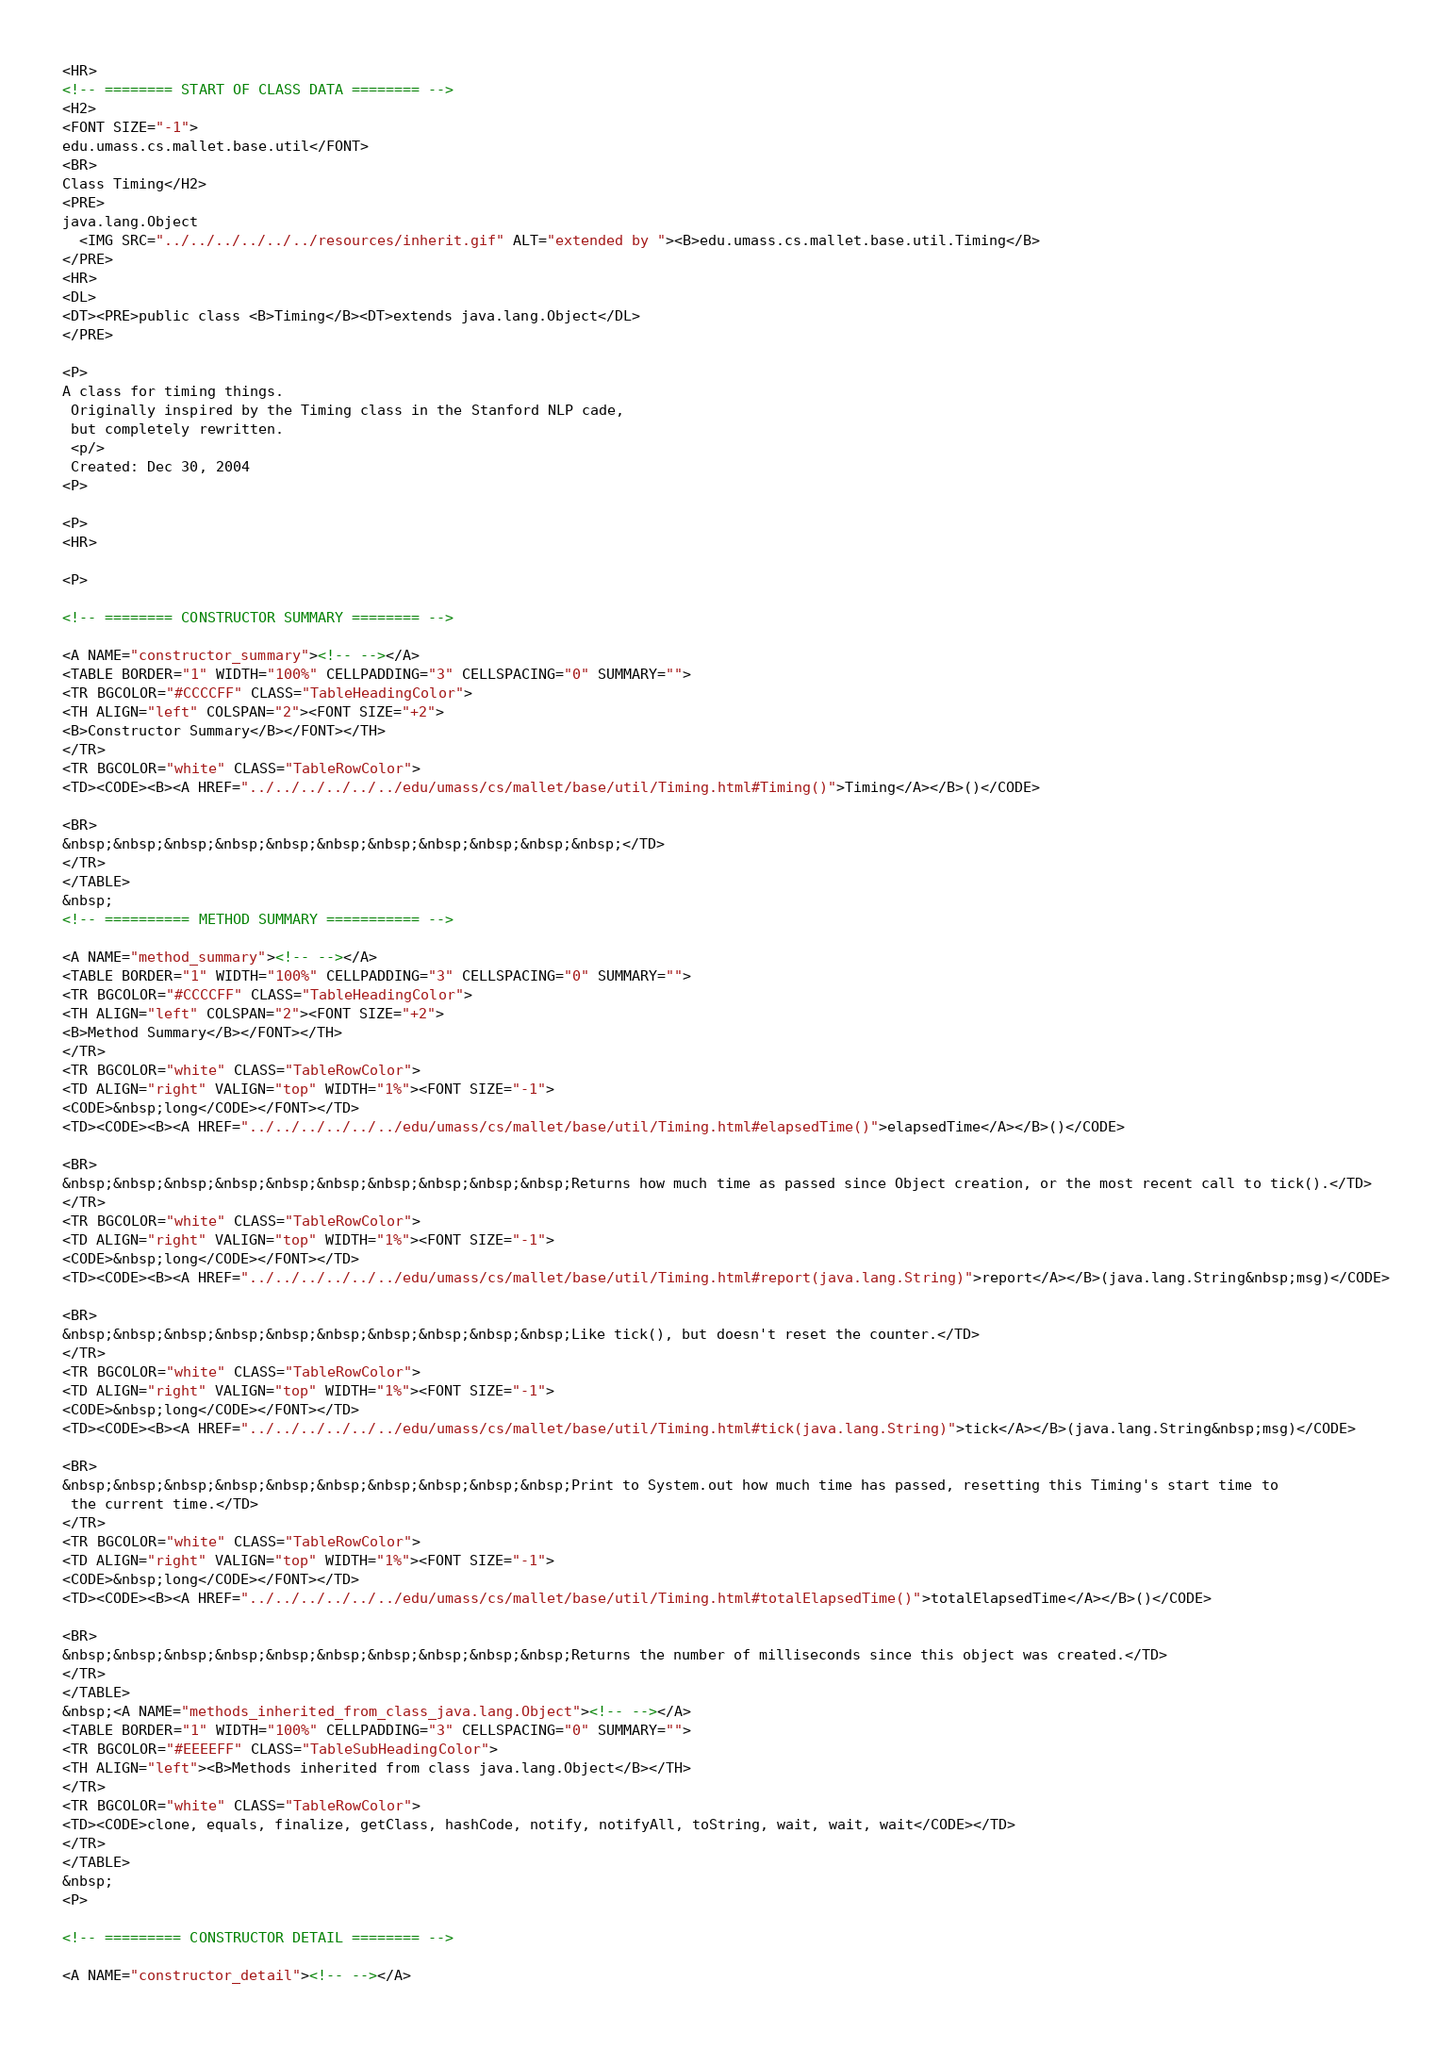<code> <loc_0><loc_0><loc_500><loc_500><_HTML_>
<HR>
<!-- ======== START OF CLASS DATA ======== -->
<H2>
<FONT SIZE="-1">
edu.umass.cs.mallet.base.util</FONT>
<BR>
Class Timing</H2>
<PRE>
java.lang.Object
  <IMG SRC="../../../../../../resources/inherit.gif" ALT="extended by "><B>edu.umass.cs.mallet.base.util.Timing</B>
</PRE>
<HR>
<DL>
<DT><PRE>public class <B>Timing</B><DT>extends java.lang.Object</DL>
</PRE>

<P>
A class for timing things.
 Originally inspired by the Timing class in the Stanford NLP cade,
 but completely rewritten.
 <p/>
 Created: Dec 30, 2004
<P>

<P>
<HR>

<P>

<!-- ======== CONSTRUCTOR SUMMARY ======== -->

<A NAME="constructor_summary"><!-- --></A>
<TABLE BORDER="1" WIDTH="100%" CELLPADDING="3" CELLSPACING="0" SUMMARY="">
<TR BGCOLOR="#CCCCFF" CLASS="TableHeadingColor">
<TH ALIGN="left" COLSPAN="2"><FONT SIZE="+2">
<B>Constructor Summary</B></FONT></TH>
</TR>
<TR BGCOLOR="white" CLASS="TableRowColor">
<TD><CODE><B><A HREF="../../../../../../edu/umass/cs/mallet/base/util/Timing.html#Timing()">Timing</A></B>()</CODE>

<BR>
&nbsp;&nbsp;&nbsp;&nbsp;&nbsp;&nbsp;&nbsp;&nbsp;&nbsp;&nbsp;&nbsp;</TD>
</TR>
</TABLE>
&nbsp;
<!-- ========== METHOD SUMMARY =========== -->

<A NAME="method_summary"><!-- --></A>
<TABLE BORDER="1" WIDTH="100%" CELLPADDING="3" CELLSPACING="0" SUMMARY="">
<TR BGCOLOR="#CCCCFF" CLASS="TableHeadingColor">
<TH ALIGN="left" COLSPAN="2"><FONT SIZE="+2">
<B>Method Summary</B></FONT></TH>
</TR>
<TR BGCOLOR="white" CLASS="TableRowColor">
<TD ALIGN="right" VALIGN="top" WIDTH="1%"><FONT SIZE="-1">
<CODE>&nbsp;long</CODE></FONT></TD>
<TD><CODE><B><A HREF="../../../../../../edu/umass/cs/mallet/base/util/Timing.html#elapsedTime()">elapsedTime</A></B>()</CODE>

<BR>
&nbsp;&nbsp;&nbsp;&nbsp;&nbsp;&nbsp;&nbsp;&nbsp;&nbsp;&nbsp;Returns how much time as passed since Object creation, or the most recent call to tick().</TD>
</TR>
<TR BGCOLOR="white" CLASS="TableRowColor">
<TD ALIGN="right" VALIGN="top" WIDTH="1%"><FONT SIZE="-1">
<CODE>&nbsp;long</CODE></FONT></TD>
<TD><CODE><B><A HREF="../../../../../../edu/umass/cs/mallet/base/util/Timing.html#report(java.lang.String)">report</A></B>(java.lang.String&nbsp;msg)</CODE>

<BR>
&nbsp;&nbsp;&nbsp;&nbsp;&nbsp;&nbsp;&nbsp;&nbsp;&nbsp;&nbsp;Like tick(), but doesn't reset the counter.</TD>
</TR>
<TR BGCOLOR="white" CLASS="TableRowColor">
<TD ALIGN="right" VALIGN="top" WIDTH="1%"><FONT SIZE="-1">
<CODE>&nbsp;long</CODE></FONT></TD>
<TD><CODE><B><A HREF="../../../../../../edu/umass/cs/mallet/base/util/Timing.html#tick(java.lang.String)">tick</A></B>(java.lang.String&nbsp;msg)</CODE>

<BR>
&nbsp;&nbsp;&nbsp;&nbsp;&nbsp;&nbsp;&nbsp;&nbsp;&nbsp;&nbsp;Print to System.out how much time has passed, resetting this Timing's start time to
 the current time.</TD>
</TR>
<TR BGCOLOR="white" CLASS="TableRowColor">
<TD ALIGN="right" VALIGN="top" WIDTH="1%"><FONT SIZE="-1">
<CODE>&nbsp;long</CODE></FONT></TD>
<TD><CODE><B><A HREF="../../../../../../edu/umass/cs/mallet/base/util/Timing.html#totalElapsedTime()">totalElapsedTime</A></B>()</CODE>

<BR>
&nbsp;&nbsp;&nbsp;&nbsp;&nbsp;&nbsp;&nbsp;&nbsp;&nbsp;&nbsp;Returns the number of milliseconds since this object was created.</TD>
</TR>
</TABLE>
&nbsp;<A NAME="methods_inherited_from_class_java.lang.Object"><!-- --></A>
<TABLE BORDER="1" WIDTH="100%" CELLPADDING="3" CELLSPACING="0" SUMMARY="">
<TR BGCOLOR="#EEEEFF" CLASS="TableSubHeadingColor">
<TH ALIGN="left"><B>Methods inherited from class java.lang.Object</B></TH>
</TR>
<TR BGCOLOR="white" CLASS="TableRowColor">
<TD><CODE>clone, equals, finalize, getClass, hashCode, notify, notifyAll, toString, wait, wait, wait</CODE></TD>
</TR>
</TABLE>
&nbsp;
<P>

<!-- ========= CONSTRUCTOR DETAIL ======== -->

<A NAME="constructor_detail"><!-- --></A></code> 